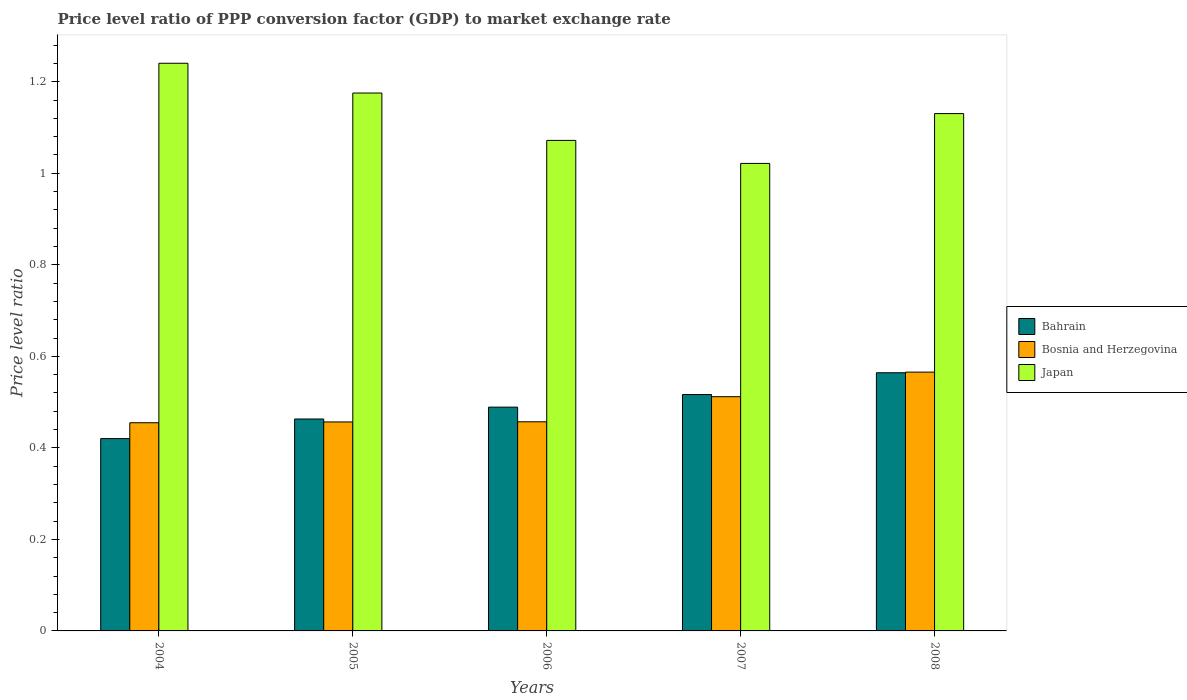How many different coloured bars are there?
Make the answer very short. 3. How many groups of bars are there?
Give a very brief answer. 5. Are the number of bars per tick equal to the number of legend labels?
Keep it short and to the point. Yes. How many bars are there on the 4th tick from the left?
Offer a terse response. 3. What is the price level ratio in Bosnia and Herzegovina in 2004?
Your answer should be compact. 0.45. Across all years, what is the maximum price level ratio in Bahrain?
Keep it short and to the point. 0.56. Across all years, what is the minimum price level ratio in Bosnia and Herzegovina?
Your answer should be compact. 0.45. In which year was the price level ratio in Japan maximum?
Provide a short and direct response. 2004. What is the total price level ratio in Bosnia and Herzegovina in the graph?
Your answer should be compact. 2.45. What is the difference between the price level ratio in Bahrain in 2007 and that in 2008?
Keep it short and to the point. -0.05. What is the difference between the price level ratio in Bosnia and Herzegovina in 2008 and the price level ratio in Japan in 2004?
Your response must be concise. -0.67. What is the average price level ratio in Bosnia and Herzegovina per year?
Offer a terse response. 0.49. In the year 2008, what is the difference between the price level ratio in Bahrain and price level ratio in Japan?
Keep it short and to the point. -0.57. What is the ratio of the price level ratio in Bahrain in 2006 to that in 2007?
Provide a short and direct response. 0.95. What is the difference between the highest and the second highest price level ratio in Bahrain?
Ensure brevity in your answer.  0.05. What is the difference between the highest and the lowest price level ratio in Japan?
Make the answer very short. 0.22. In how many years, is the price level ratio in Japan greater than the average price level ratio in Japan taken over all years?
Ensure brevity in your answer.  3. What does the 2nd bar from the left in 2006 represents?
Ensure brevity in your answer.  Bosnia and Herzegovina. What does the 3rd bar from the right in 2008 represents?
Provide a succinct answer. Bahrain. How many bars are there?
Keep it short and to the point. 15. How many years are there in the graph?
Your answer should be very brief. 5. What is the difference between two consecutive major ticks on the Y-axis?
Make the answer very short. 0.2. Does the graph contain any zero values?
Offer a very short reply. No. Does the graph contain grids?
Ensure brevity in your answer.  No. Where does the legend appear in the graph?
Provide a short and direct response. Center right. How many legend labels are there?
Offer a terse response. 3. How are the legend labels stacked?
Your answer should be very brief. Vertical. What is the title of the graph?
Your response must be concise. Price level ratio of PPP conversion factor (GDP) to market exchange rate. What is the label or title of the Y-axis?
Give a very brief answer. Price level ratio. What is the Price level ratio of Bahrain in 2004?
Offer a terse response. 0.42. What is the Price level ratio in Bosnia and Herzegovina in 2004?
Give a very brief answer. 0.45. What is the Price level ratio in Japan in 2004?
Offer a very short reply. 1.24. What is the Price level ratio of Bahrain in 2005?
Your answer should be very brief. 0.46. What is the Price level ratio in Bosnia and Herzegovina in 2005?
Give a very brief answer. 0.46. What is the Price level ratio in Japan in 2005?
Make the answer very short. 1.18. What is the Price level ratio in Bahrain in 2006?
Make the answer very short. 0.49. What is the Price level ratio in Bosnia and Herzegovina in 2006?
Offer a terse response. 0.46. What is the Price level ratio in Japan in 2006?
Your answer should be very brief. 1.07. What is the Price level ratio of Bahrain in 2007?
Make the answer very short. 0.52. What is the Price level ratio of Bosnia and Herzegovina in 2007?
Provide a succinct answer. 0.51. What is the Price level ratio in Japan in 2007?
Offer a terse response. 1.02. What is the Price level ratio in Bahrain in 2008?
Your answer should be very brief. 0.56. What is the Price level ratio in Bosnia and Herzegovina in 2008?
Offer a terse response. 0.57. What is the Price level ratio in Japan in 2008?
Provide a short and direct response. 1.13. Across all years, what is the maximum Price level ratio of Bahrain?
Ensure brevity in your answer.  0.56. Across all years, what is the maximum Price level ratio of Bosnia and Herzegovina?
Ensure brevity in your answer.  0.57. Across all years, what is the maximum Price level ratio in Japan?
Ensure brevity in your answer.  1.24. Across all years, what is the minimum Price level ratio of Bahrain?
Provide a succinct answer. 0.42. Across all years, what is the minimum Price level ratio in Bosnia and Herzegovina?
Provide a short and direct response. 0.45. Across all years, what is the minimum Price level ratio of Japan?
Give a very brief answer. 1.02. What is the total Price level ratio of Bahrain in the graph?
Provide a short and direct response. 2.45. What is the total Price level ratio of Bosnia and Herzegovina in the graph?
Your answer should be compact. 2.45. What is the total Price level ratio of Japan in the graph?
Provide a succinct answer. 5.64. What is the difference between the Price level ratio in Bahrain in 2004 and that in 2005?
Ensure brevity in your answer.  -0.04. What is the difference between the Price level ratio of Bosnia and Herzegovina in 2004 and that in 2005?
Keep it short and to the point. -0. What is the difference between the Price level ratio in Japan in 2004 and that in 2005?
Your answer should be compact. 0.07. What is the difference between the Price level ratio in Bahrain in 2004 and that in 2006?
Make the answer very short. -0.07. What is the difference between the Price level ratio in Bosnia and Herzegovina in 2004 and that in 2006?
Your response must be concise. -0. What is the difference between the Price level ratio in Japan in 2004 and that in 2006?
Give a very brief answer. 0.17. What is the difference between the Price level ratio of Bahrain in 2004 and that in 2007?
Give a very brief answer. -0.1. What is the difference between the Price level ratio in Bosnia and Herzegovina in 2004 and that in 2007?
Make the answer very short. -0.06. What is the difference between the Price level ratio of Japan in 2004 and that in 2007?
Provide a succinct answer. 0.22. What is the difference between the Price level ratio in Bahrain in 2004 and that in 2008?
Your answer should be compact. -0.14. What is the difference between the Price level ratio in Bosnia and Herzegovina in 2004 and that in 2008?
Your answer should be very brief. -0.11. What is the difference between the Price level ratio of Japan in 2004 and that in 2008?
Provide a succinct answer. 0.11. What is the difference between the Price level ratio of Bahrain in 2005 and that in 2006?
Give a very brief answer. -0.03. What is the difference between the Price level ratio in Bosnia and Herzegovina in 2005 and that in 2006?
Your answer should be compact. -0. What is the difference between the Price level ratio of Japan in 2005 and that in 2006?
Make the answer very short. 0.1. What is the difference between the Price level ratio in Bahrain in 2005 and that in 2007?
Give a very brief answer. -0.05. What is the difference between the Price level ratio of Bosnia and Herzegovina in 2005 and that in 2007?
Offer a very short reply. -0.06. What is the difference between the Price level ratio of Japan in 2005 and that in 2007?
Your answer should be very brief. 0.15. What is the difference between the Price level ratio in Bahrain in 2005 and that in 2008?
Give a very brief answer. -0.1. What is the difference between the Price level ratio in Bosnia and Herzegovina in 2005 and that in 2008?
Make the answer very short. -0.11. What is the difference between the Price level ratio of Japan in 2005 and that in 2008?
Give a very brief answer. 0.04. What is the difference between the Price level ratio of Bahrain in 2006 and that in 2007?
Your response must be concise. -0.03. What is the difference between the Price level ratio in Bosnia and Herzegovina in 2006 and that in 2007?
Your response must be concise. -0.05. What is the difference between the Price level ratio of Japan in 2006 and that in 2007?
Your answer should be very brief. 0.05. What is the difference between the Price level ratio in Bahrain in 2006 and that in 2008?
Your answer should be compact. -0.08. What is the difference between the Price level ratio of Bosnia and Herzegovina in 2006 and that in 2008?
Provide a short and direct response. -0.11. What is the difference between the Price level ratio in Japan in 2006 and that in 2008?
Your answer should be very brief. -0.06. What is the difference between the Price level ratio of Bahrain in 2007 and that in 2008?
Give a very brief answer. -0.05. What is the difference between the Price level ratio of Bosnia and Herzegovina in 2007 and that in 2008?
Give a very brief answer. -0.05. What is the difference between the Price level ratio in Japan in 2007 and that in 2008?
Your answer should be compact. -0.11. What is the difference between the Price level ratio in Bahrain in 2004 and the Price level ratio in Bosnia and Herzegovina in 2005?
Offer a terse response. -0.04. What is the difference between the Price level ratio in Bahrain in 2004 and the Price level ratio in Japan in 2005?
Provide a succinct answer. -0.76. What is the difference between the Price level ratio in Bosnia and Herzegovina in 2004 and the Price level ratio in Japan in 2005?
Offer a very short reply. -0.72. What is the difference between the Price level ratio in Bahrain in 2004 and the Price level ratio in Bosnia and Herzegovina in 2006?
Your response must be concise. -0.04. What is the difference between the Price level ratio of Bahrain in 2004 and the Price level ratio of Japan in 2006?
Make the answer very short. -0.65. What is the difference between the Price level ratio in Bosnia and Herzegovina in 2004 and the Price level ratio in Japan in 2006?
Your response must be concise. -0.62. What is the difference between the Price level ratio of Bahrain in 2004 and the Price level ratio of Bosnia and Herzegovina in 2007?
Offer a terse response. -0.09. What is the difference between the Price level ratio in Bahrain in 2004 and the Price level ratio in Japan in 2007?
Your response must be concise. -0.6. What is the difference between the Price level ratio of Bosnia and Herzegovina in 2004 and the Price level ratio of Japan in 2007?
Provide a short and direct response. -0.57. What is the difference between the Price level ratio of Bahrain in 2004 and the Price level ratio of Bosnia and Herzegovina in 2008?
Offer a very short reply. -0.15. What is the difference between the Price level ratio in Bahrain in 2004 and the Price level ratio in Japan in 2008?
Your answer should be compact. -0.71. What is the difference between the Price level ratio of Bosnia and Herzegovina in 2004 and the Price level ratio of Japan in 2008?
Offer a terse response. -0.68. What is the difference between the Price level ratio in Bahrain in 2005 and the Price level ratio in Bosnia and Herzegovina in 2006?
Offer a very short reply. 0.01. What is the difference between the Price level ratio in Bahrain in 2005 and the Price level ratio in Japan in 2006?
Make the answer very short. -0.61. What is the difference between the Price level ratio of Bosnia and Herzegovina in 2005 and the Price level ratio of Japan in 2006?
Make the answer very short. -0.62. What is the difference between the Price level ratio of Bahrain in 2005 and the Price level ratio of Bosnia and Herzegovina in 2007?
Offer a terse response. -0.05. What is the difference between the Price level ratio of Bahrain in 2005 and the Price level ratio of Japan in 2007?
Provide a succinct answer. -0.56. What is the difference between the Price level ratio in Bosnia and Herzegovina in 2005 and the Price level ratio in Japan in 2007?
Your response must be concise. -0.56. What is the difference between the Price level ratio in Bahrain in 2005 and the Price level ratio in Bosnia and Herzegovina in 2008?
Ensure brevity in your answer.  -0.1. What is the difference between the Price level ratio in Bahrain in 2005 and the Price level ratio in Japan in 2008?
Ensure brevity in your answer.  -0.67. What is the difference between the Price level ratio of Bosnia and Herzegovina in 2005 and the Price level ratio of Japan in 2008?
Make the answer very short. -0.67. What is the difference between the Price level ratio of Bahrain in 2006 and the Price level ratio of Bosnia and Herzegovina in 2007?
Provide a succinct answer. -0.02. What is the difference between the Price level ratio in Bahrain in 2006 and the Price level ratio in Japan in 2007?
Your answer should be very brief. -0.53. What is the difference between the Price level ratio of Bosnia and Herzegovina in 2006 and the Price level ratio of Japan in 2007?
Provide a succinct answer. -0.56. What is the difference between the Price level ratio of Bahrain in 2006 and the Price level ratio of Bosnia and Herzegovina in 2008?
Provide a succinct answer. -0.08. What is the difference between the Price level ratio of Bahrain in 2006 and the Price level ratio of Japan in 2008?
Offer a very short reply. -0.64. What is the difference between the Price level ratio of Bosnia and Herzegovina in 2006 and the Price level ratio of Japan in 2008?
Offer a terse response. -0.67. What is the difference between the Price level ratio of Bahrain in 2007 and the Price level ratio of Bosnia and Herzegovina in 2008?
Provide a short and direct response. -0.05. What is the difference between the Price level ratio in Bahrain in 2007 and the Price level ratio in Japan in 2008?
Your response must be concise. -0.61. What is the difference between the Price level ratio in Bosnia and Herzegovina in 2007 and the Price level ratio in Japan in 2008?
Make the answer very short. -0.62. What is the average Price level ratio in Bahrain per year?
Offer a terse response. 0.49. What is the average Price level ratio in Bosnia and Herzegovina per year?
Make the answer very short. 0.49. What is the average Price level ratio of Japan per year?
Give a very brief answer. 1.13. In the year 2004, what is the difference between the Price level ratio in Bahrain and Price level ratio in Bosnia and Herzegovina?
Your answer should be compact. -0.03. In the year 2004, what is the difference between the Price level ratio of Bahrain and Price level ratio of Japan?
Offer a terse response. -0.82. In the year 2004, what is the difference between the Price level ratio in Bosnia and Herzegovina and Price level ratio in Japan?
Keep it short and to the point. -0.79. In the year 2005, what is the difference between the Price level ratio in Bahrain and Price level ratio in Bosnia and Herzegovina?
Offer a terse response. 0.01. In the year 2005, what is the difference between the Price level ratio in Bahrain and Price level ratio in Japan?
Offer a terse response. -0.71. In the year 2005, what is the difference between the Price level ratio of Bosnia and Herzegovina and Price level ratio of Japan?
Ensure brevity in your answer.  -0.72. In the year 2006, what is the difference between the Price level ratio in Bahrain and Price level ratio in Bosnia and Herzegovina?
Give a very brief answer. 0.03. In the year 2006, what is the difference between the Price level ratio in Bahrain and Price level ratio in Japan?
Provide a short and direct response. -0.58. In the year 2006, what is the difference between the Price level ratio of Bosnia and Herzegovina and Price level ratio of Japan?
Your answer should be compact. -0.61. In the year 2007, what is the difference between the Price level ratio in Bahrain and Price level ratio in Bosnia and Herzegovina?
Ensure brevity in your answer.  0. In the year 2007, what is the difference between the Price level ratio in Bahrain and Price level ratio in Japan?
Offer a very short reply. -0.51. In the year 2007, what is the difference between the Price level ratio in Bosnia and Herzegovina and Price level ratio in Japan?
Your answer should be compact. -0.51. In the year 2008, what is the difference between the Price level ratio in Bahrain and Price level ratio in Bosnia and Herzegovina?
Your response must be concise. -0. In the year 2008, what is the difference between the Price level ratio of Bahrain and Price level ratio of Japan?
Your answer should be very brief. -0.57. In the year 2008, what is the difference between the Price level ratio in Bosnia and Herzegovina and Price level ratio in Japan?
Give a very brief answer. -0.56. What is the ratio of the Price level ratio of Bahrain in 2004 to that in 2005?
Offer a very short reply. 0.91. What is the ratio of the Price level ratio of Bosnia and Herzegovina in 2004 to that in 2005?
Make the answer very short. 1. What is the ratio of the Price level ratio in Japan in 2004 to that in 2005?
Ensure brevity in your answer.  1.06. What is the ratio of the Price level ratio in Bahrain in 2004 to that in 2006?
Offer a very short reply. 0.86. What is the ratio of the Price level ratio of Bosnia and Herzegovina in 2004 to that in 2006?
Offer a very short reply. 1. What is the ratio of the Price level ratio of Japan in 2004 to that in 2006?
Provide a succinct answer. 1.16. What is the ratio of the Price level ratio of Bahrain in 2004 to that in 2007?
Ensure brevity in your answer.  0.81. What is the ratio of the Price level ratio of Bosnia and Herzegovina in 2004 to that in 2007?
Provide a succinct answer. 0.89. What is the ratio of the Price level ratio of Japan in 2004 to that in 2007?
Ensure brevity in your answer.  1.21. What is the ratio of the Price level ratio of Bahrain in 2004 to that in 2008?
Keep it short and to the point. 0.74. What is the ratio of the Price level ratio of Bosnia and Herzegovina in 2004 to that in 2008?
Keep it short and to the point. 0.8. What is the ratio of the Price level ratio of Japan in 2004 to that in 2008?
Provide a short and direct response. 1.1. What is the ratio of the Price level ratio of Bahrain in 2005 to that in 2006?
Provide a short and direct response. 0.95. What is the ratio of the Price level ratio in Bosnia and Herzegovina in 2005 to that in 2006?
Make the answer very short. 1. What is the ratio of the Price level ratio in Japan in 2005 to that in 2006?
Ensure brevity in your answer.  1.1. What is the ratio of the Price level ratio in Bahrain in 2005 to that in 2007?
Offer a very short reply. 0.9. What is the ratio of the Price level ratio in Bosnia and Herzegovina in 2005 to that in 2007?
Keep it short and to the point. 0.89. What is the ratio of the Price level ratio of Japan in 2005 to that in 2007?
Your answer should be very brief. 1.15. What is the ratio of the Price level ratio of Bahrain in 2005 to that in 2008?
Your response must be concise. 0.82. What is the ratio of the Price level ratio of Bosnia and Herzegovina in 2005 to that in 2008?
Ensure brevity in your answer.  0.81. What is the ratio of the Price level ratio in Japan in 2005 to that in 2008?
Ensure brevity in your answer.  1.04. What is the ratio of the Price level ratio in Bahrain in 2006 to that in 2007?
Make the answer very short. 0.95. What is the ratio of the Price level ratio in Bosnia and Herzegovina in 2006 to that in 2007?
Make the answer very short. 0.89. What is the ratio of the Price level ratio of Japan in 2006 to that in 2007?
Your answer should be very brief. 1.05. What is the ratio of the Price level ratio in Bahrain in 2006 to that in 2008?
Your answer should be compact. 0.87. What is the ratio of the Price level ratio of Bosnia and Herzegovina in 2006 to that in 2008?
Your answer should be compact. 0.81. What is the ratio of the Price level ratio in Japan in 2006 to that in 2008?
Keep it short and to the point. 0.95. What is the ratio of the Price level ratio of Bahrain in 2007 to that in 2008?
Offer a terse response. 0.92. What is the ratio of the Price level ratio of Bosnia and Herzegovina in 2007 to that in 2008?
Your response must be concise. 0.91. What is the ratio of the Price level ratio of Japan in 2007 to that in 2008?
Offer a very short reply. 0.9. What is the difference between the highest and the second highest Price level ratio in Bahrain?
Your answer should be very brief. 0.05. What is the difference between the highest and the second highest Price level ratio of Bosnia and Herzegovina?
Offer a terse response. 0.05. What is the difference between the highest and the second highest Price level ratio in Japan?
Offer a terse response. 0.07. What is the difference between the highest and the lowest Price level ratio of Bahrain?
Your answer should be compact. 0.14. What is the difference between the highest and the lowest Price level ratio in Bosnia and Herzegovina?
Ensure brevity in your answer.  0.11. What is the difference between the highest and the lowest Price level ratio in Japan?
Give a very brief answer. 0.22. 